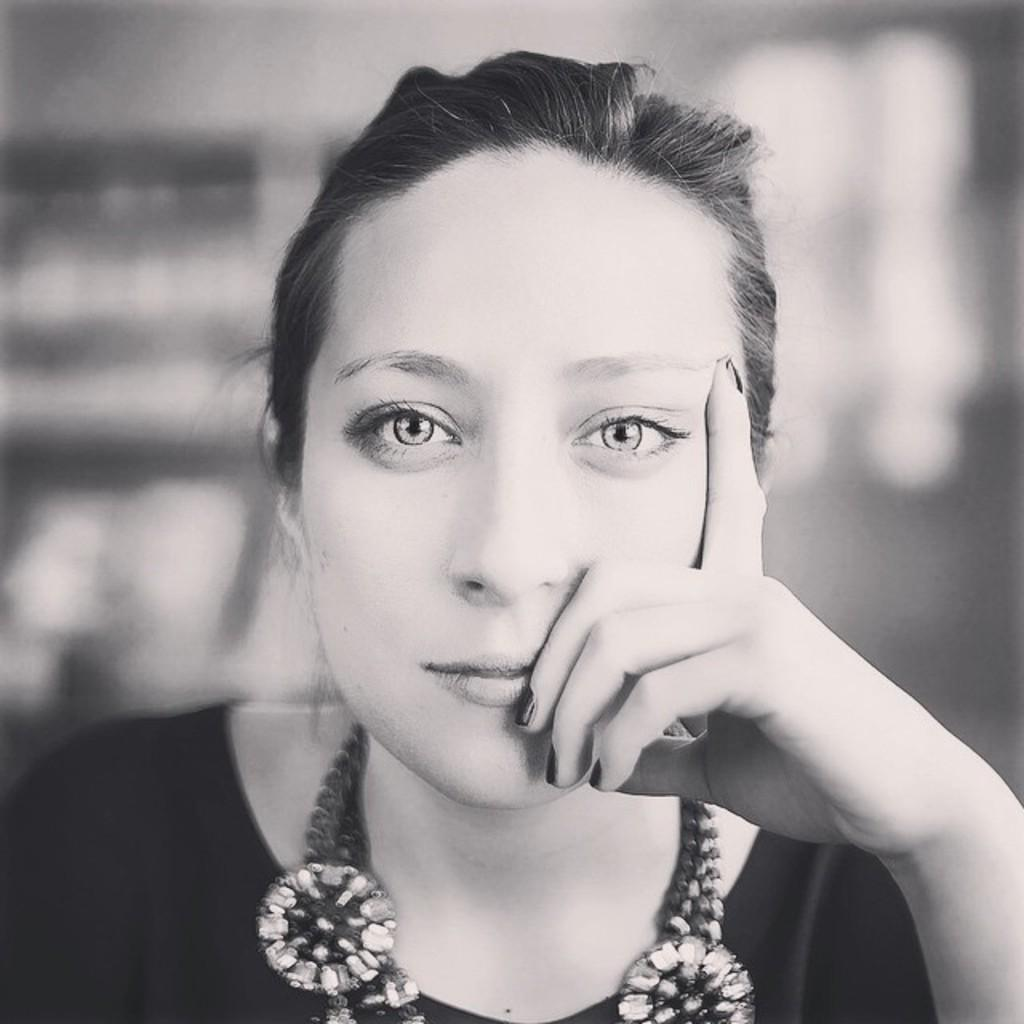What is the color scheme of the image? The image is black and white. Can you describe the main subject of the image? There is a woman in the image. How would you describe the background of the image? The background of the image is blurry. What type of engine can be seen in the background of the image? There is no engine present in the image; it is a black and white image of a woman with a blurry background. 